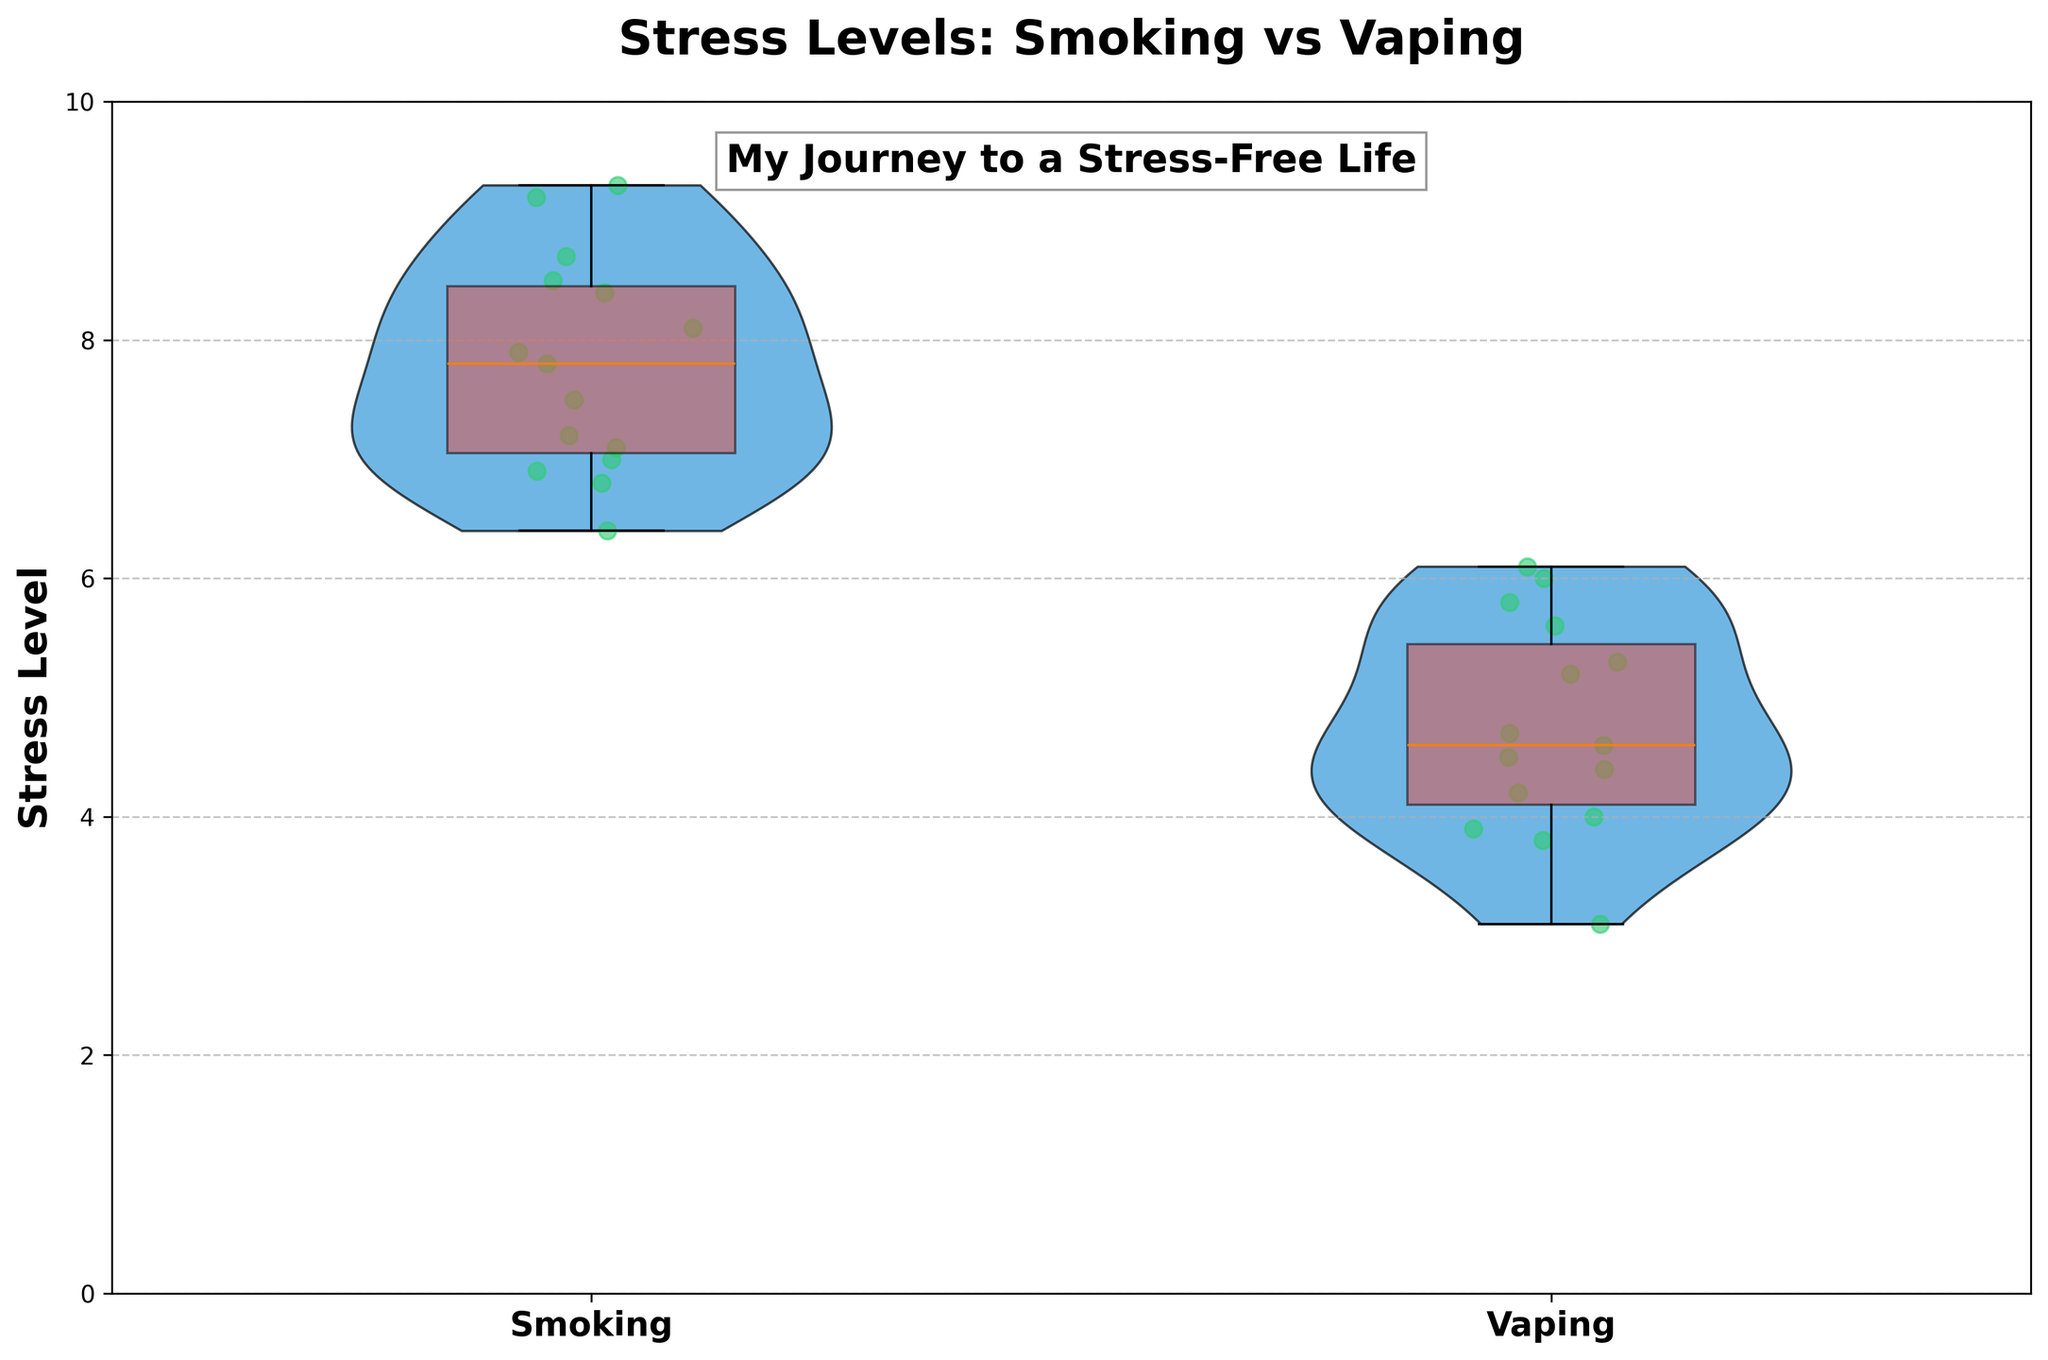What is the title of the plot? The title of the plot is displayed at the top center of the figure.
Answer: Stress Levels: Smoking vs Vaping What are the two groups compared in the plot? The x-axis labels indicate the names of the two groups compared in the plot.
Answer: Smoking and Vaping Which group shows lower stress levels overall? By observing the positions of the plots and the distribution of the data points, we can see that the Vaping group has lower stress levels overall.
Answer: Vaping What is the color used for the violin plots? The color of the violin plots can be identified by looking at the bodies of the violins.
Answer: Blue How are the individual data points represented in the plot? The individual data points are represented by scattered points with a slight horizontal jitter to prevent overlap.
Answer: Scattered green points What is the range of stress levels shown on the y-axis? The range of stress levels can be seen from the y-axis labels.
Answer: 0 to 10 How many data points are plotted in each group? By counting the number of scattered points, we can determine the number of data points in each group.
Answer: 15 per group What visual feature is used to represent the variability within each group? The variability within each group is represented by the width of the violin plots and the individual data points scattered within the violins.
Answer: Width of the violin plots and scattered points Compare the median stress levels of smoking and vaping groups. The median stress levels can be approximated by the central tendencies of the box plots embedded within the violin plots. The Vaping group has a lower median stress level compared to the Smoking group.
Answer: Vaping has a lower median What can you infer about the difference in stress levels between traditional smoking and vaping from the plot? The overall lower stress levels in the Vaping group compared to the Smoking group suggest that switching to vaping may have helped reduce stress levels. This is indicated by the lower positions of data points and a more compact violin plot for Vaping.
Answer: Vaping likely reduces stress levels compared to smoking 